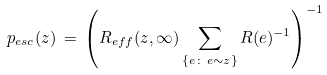Convert formula to latex. <formula><loc_0><loc_0><loc_500><loc_500>p _ { e s c } ( z ) \, = \, \left ( R _ { e f f } ( z , \infty ) \sum _ { \{ e \colon \, e \sim z \} } R ( e ) ^ { - 1 } \right ) ^ { - 1 }</formula> 